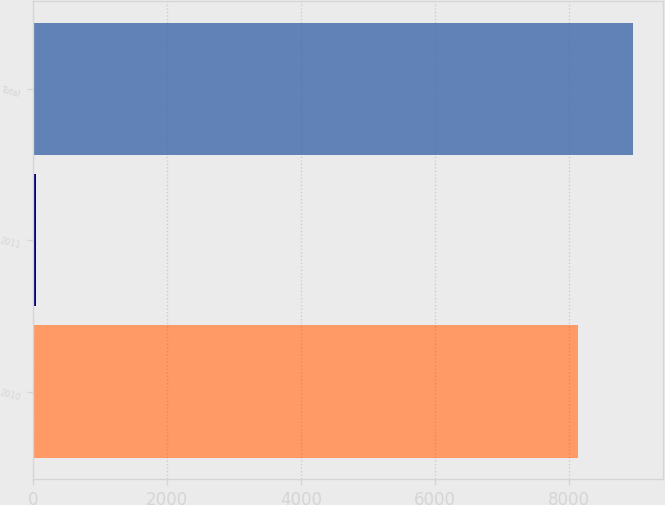<chart> <loc_0><loc_0><loc_500><loc_500><bar_chart><fcel>2010<fcel>2011<fcel>Total<nl><fcel>8132<fcel>43<fcel>8945.2<nl></chart> 